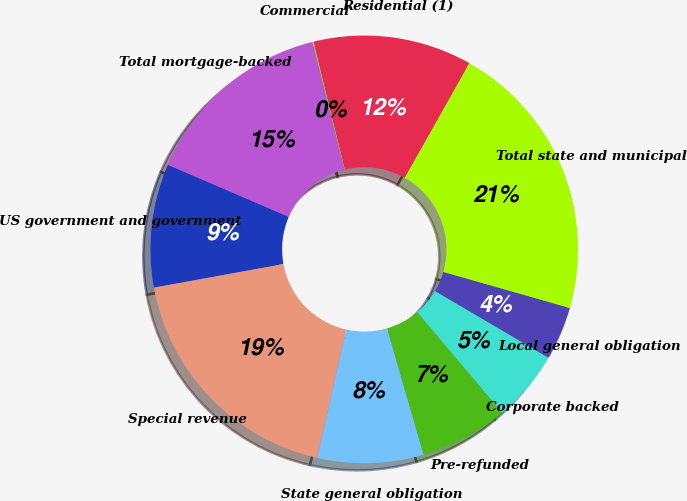Convert chart to OTSL. <chart><loc_0><loc_0><loc_500><loc_500><pie_chart><fcel>US government and government<fcel>Special revenue<fcel>State general obligation<fcel>Pre-refunded<fcel>Corporate backed<fcel>Local general obligation<fcel>Total state and municipal<fcel>Residential (1)<fcel>Commercial<fcel>Total mortgage-backed<nl><fcel>9.34%<fcel>18.6%<fcel>8.01%<fcel>6.69%<fcel>5.37%<fcel>4.04%<fcel>21.25%<fcel>11.99%<fcel>0.07%<fcel>14.63%<nl></chart> 